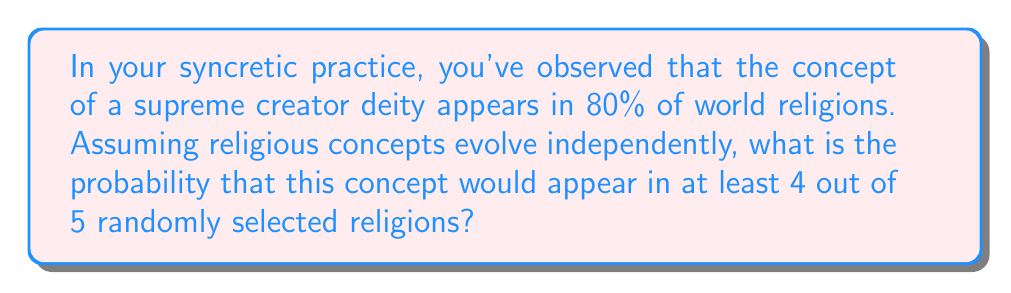Show me your answer to this math problem. Let's approach this step-by-step using the binomial probability distribution:

1) Let $p = 0.80$ be the probability of a religion having the concept of a supreme creator deity.

2) We want to find $P(X \geq 4)$ where $X$ is the number of religions with this concept out of 5 randomly selected religions.

3) This is equivalent to $1 - P(X \leq 3)$

4) Using the binomial probability formula:

   $P(X = k) = \binom{n}{k} p^k (1-p)^{n-k}$

   where $n = 5$ (total religions selected) and $k$ is the number of successes.

5) Calculate probabilities for $k = 0, 1, 2, 3$:

   $P(X = 0) = \binom{5}{0} (0.8)^0 (0.2)^5 = 0.00032$
   $P(X = 1) = \binom{5}{1} (0.8)^1 (0.2)^4 = 0.00640$
   $P(X = 2) = \binom{5}{2} (0.8)^2 (0.2)^3 = 0.05120$
   $P(X = 3) = \binom{5}{3} (0.8)^3 (0.2)^2 = 0.20480$

6) Sum these probabilities:

   $P(X \leq 3) = 0.00032 + 0.00640 + 0.05120 + 0.20480 = 0.26272$

7) Therefore, $P(X \geq 4) = 1 - P(X \leq 3) = 1 - 0.26272 = 0.73728$
Answer: $0.73728$ or $73.728\%$ 